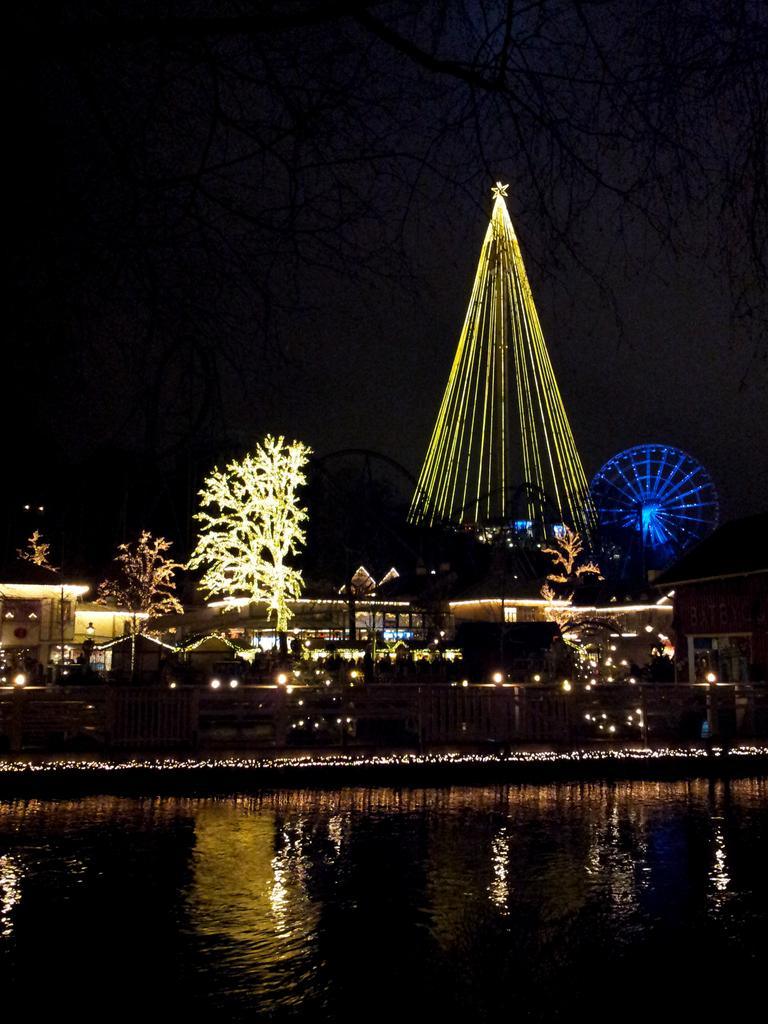What type of building is in the image? There is a house in the image. What feature can be seen on the house? The house has decorative lights. What is present in the background of the image? There is a Christmas tree with lights and a dark sky in the background. What can be seen at the bottom of the image? There is water visible in the front bottom side of the image. What type of advertisement can be seen on the side of the house? There is no advertisement present on the side of the house in the image. How many mothers are visible in the image? There are no people, including mothers, visible in the image. 